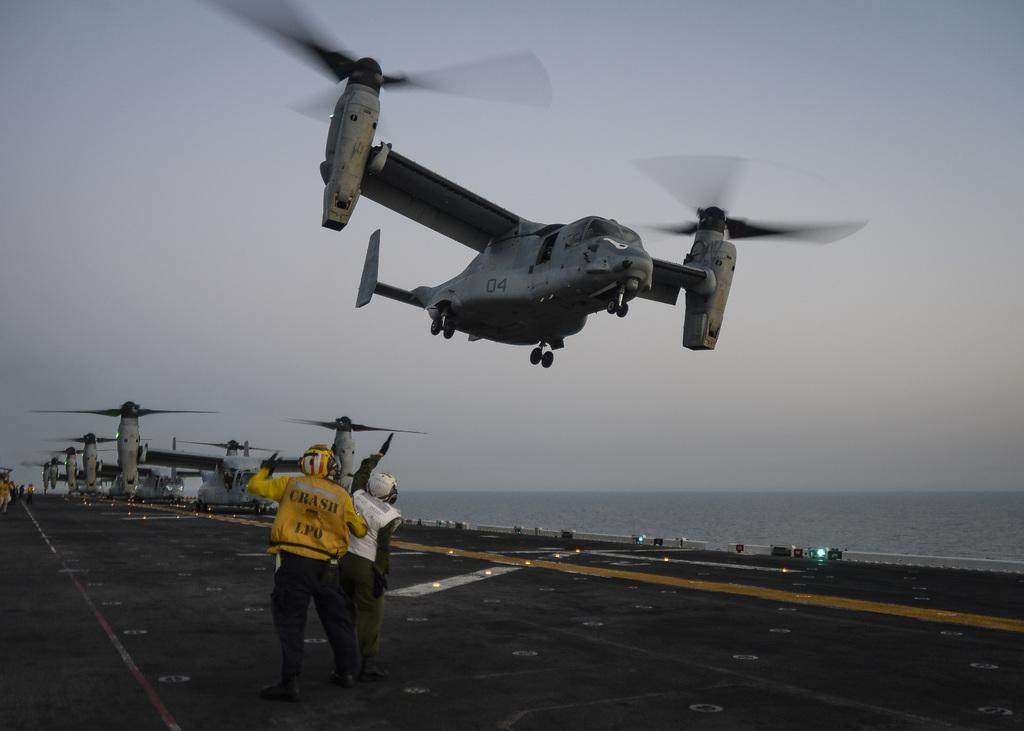<image>
Write a terse but informative summary of the picture. Two men with one wearing a yellow jacket with the word crash on it watch a helicopter take off from an aircraft carrier. 